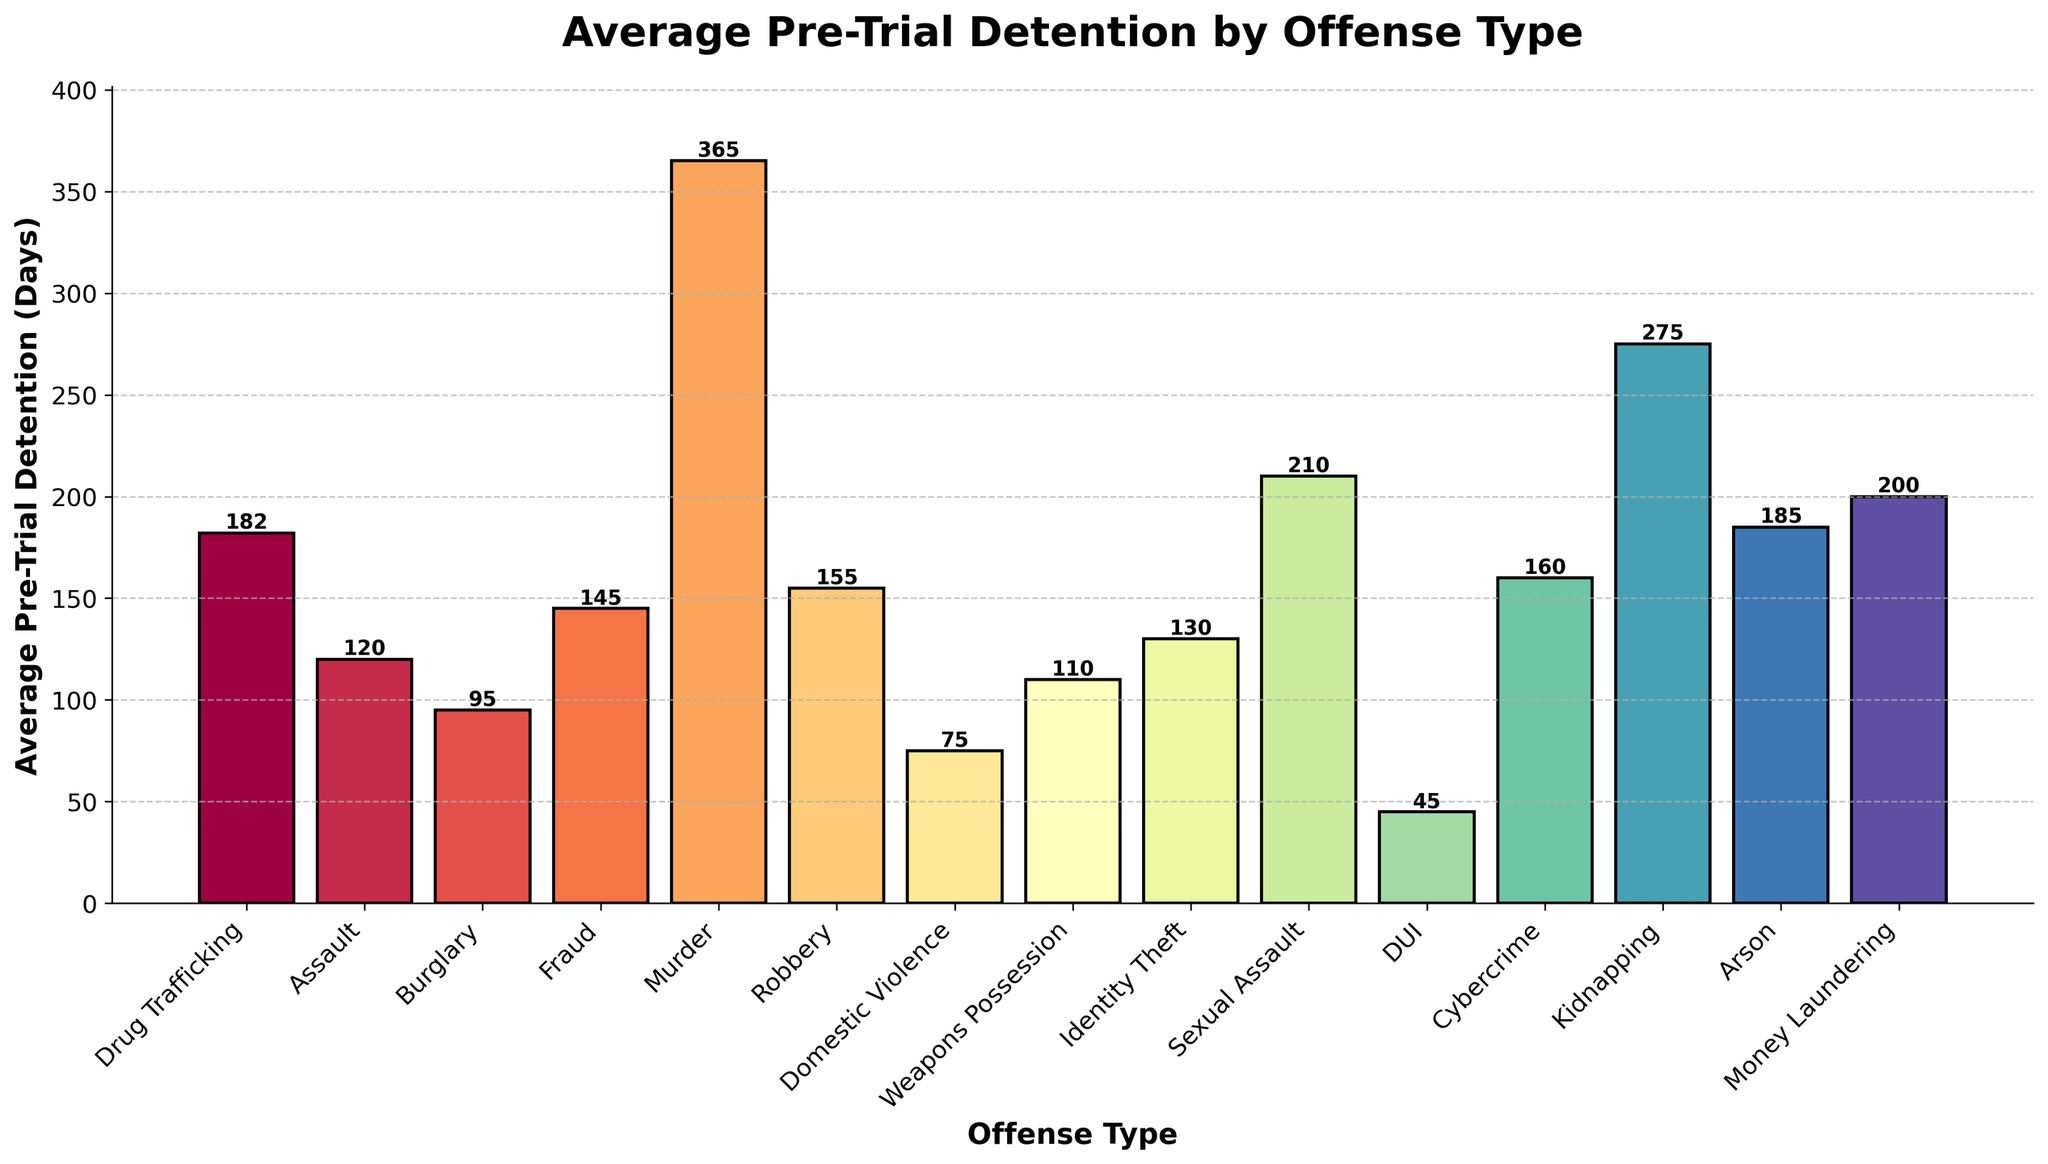What's the average length of pre-trial detention for Drug Trafficking and Murder combined? To find the average length of pre-trial detention for Drug Trafficking and Murder, add the detention periods for both offenses together and divide by 2. Drug Trafficking has 182 days and Murder has 365 days. (182 + 365) = 547. Now divide by 2. So, 547 / 2 = 273.5
Answer: 273.5 Which offense type has the shortest average pre-trial detention period? Look for the bar with the smallest height. The shortest bar corresponds to DUI, which has an average pre-trial detention of 45 days.
Answer: DUI Are there any offense types with exactly 130 days of average pre-trial detention? Look for a bar marked with the number 130 at its top. The offense type is Identity Theft.
Answer: Identity Theft Which offense type has a longer average pre-trial detention period: Assault or Cybercrime? Compare the heights of the bars labeled Assault and Cybercrime. Assault has 120 days while Cybercrime has 160 days. Cybercrime has a longer pre-trial detention period.
Answer: Cybercrime How many offense types have an average pre-trial detention of more than 200 days? Count the number of bars exceeding the 200-day mark. These offense types are Murder, Sexual Assault, Kidnapping, Arson, and Money Laundering, making a total of 5.
Answer: 5 What’s the difference in average pre-trial detention between Robbery and Fraud? Find the difference by subtracting the average pre-trial detention of Fraud from that of Robbery. Robbery has 155 days, and Fraud has 145 days. (155 - 145) = 10 days.
Answer: 10 Which two offense types have the most similar average pre-trial detention periods? Look for the two bars that are closest in height. Weapon Possession and Assault are close: Weapon Possession is at 110 days, and Assault is at 120 days. They differ by 10 days, the smallest difference among all pairs.
Answer: Weapon Possession and Assault What’s the total average pre-trial detention for Burglary, Fraud, and Domestic Violence combined? Add the average pre-trial detention periods for Burglary, Fraud, and Domestic Violence. Burglary has 95 days, Fraud has 145 days, and Domestic Violence has 75 days. (95 + 145 + 75) = 315 days
Answer: 315 Is the average pre-trial detention for Arson longer than that for Cybercrime? Compare the heights of the bars labeled Arson and Cybercrime. Arson has 185 days, whereas Cybercrime has 160 days. Arson has a longer pre-trial detention period.
Answer: Yes What’s the range of average pre-trial detention periods (difference between the maximum and minimum values)? Find the maximum value (Murder: 365 days) and the minimum value (DUI: 45 days). Subtract the minimum from the maximum to find the range: (365 - 45) = 320 days.
Answer: 320 